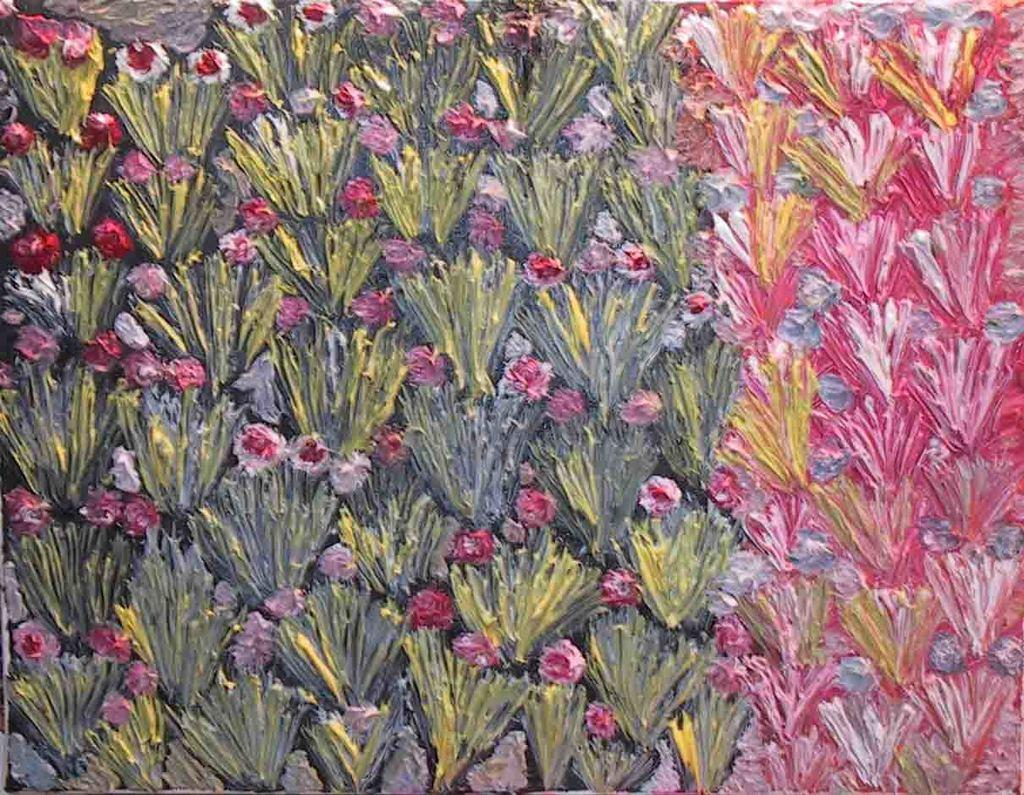What is the main subject of the painting? The painting contains flowers. What colors are used for the flowers in the painting? The flowers are painted in pink and white colors. Are there any other elements in the painting besides flowers? Yes, the painting includes green leaves. Can you see any goldfish swimming in the painting? There are no goldfish present in the painting; it features flowers and green leaves. 